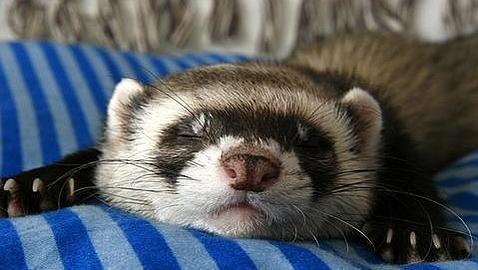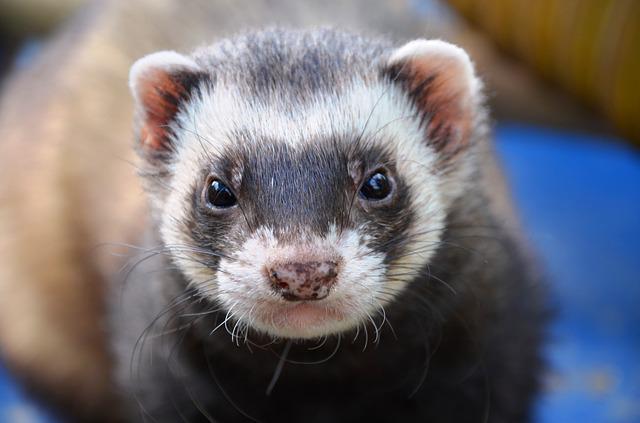The first image is the image on the left, the second image is the image on the right. Considering the images on both sides, is "One ferret has its tongue sticking out." valid? Answer yes or no. No. The first image is the image on the left, the second image is the image on the right. For the images shown, is this caption "Not even one of the animals appears to be awake and alert; they all seem tired, or are sleeping." true? Answer yes or no. No. 